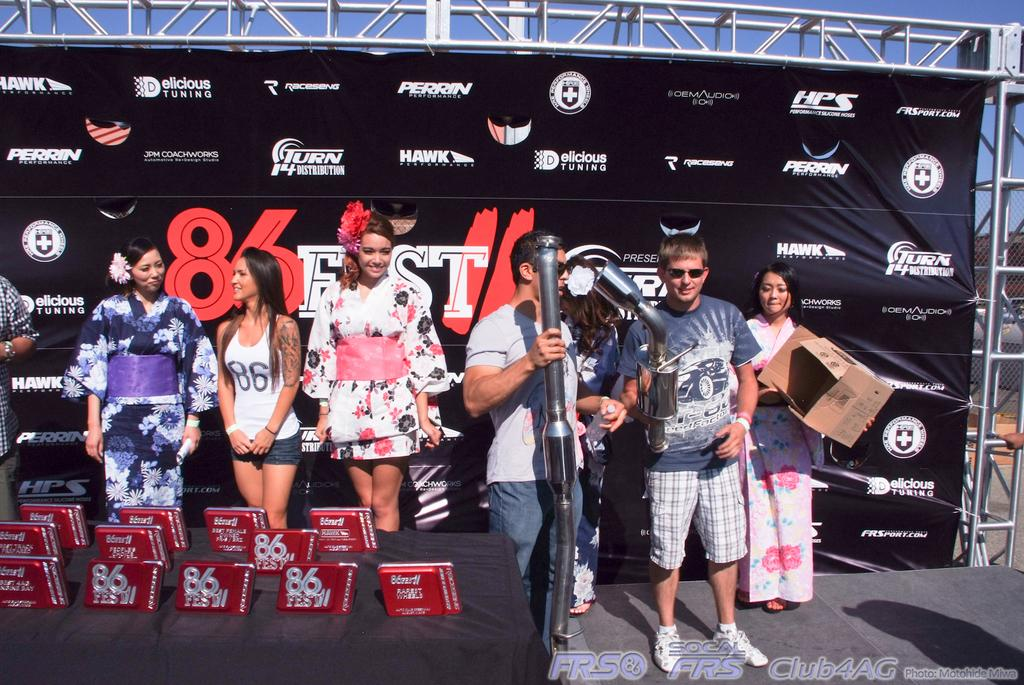<image>
Render a clear and concise summary of the photo. a group of people at an event with 86 behind them on a sign 